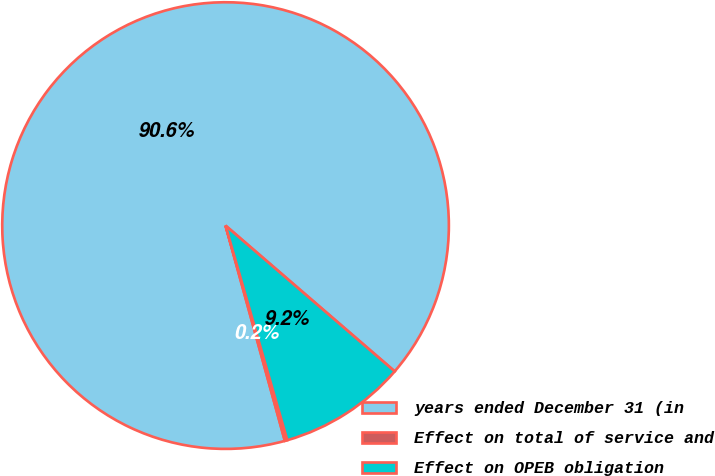Convert chart. <chart><loc_0><loc_0><loc_500><loc_500><pie_chart><fcel>years ended December 31 (in<fcel>Effect on total of service and<fcel>Effect on OPEB obligation<nl><fcel>90.6%<fcel>0.18%<fcel>9.22%<nl></chart> 